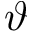<formula> <loc_0><loc_0><loc_500><loc_500>\vartheta</formula> 